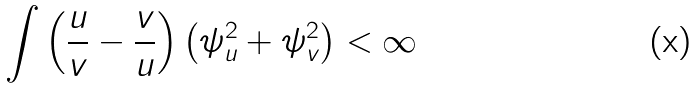<formula> <loc_0><loc_0><loc_500><loc_500>\int \left ( \frac { u } { v } - \frac { v } { u } \right ) \left ( \psi _ { u } ^ { 2 } + \psi _ { v } ^ { 2 } \right ) < \infty</formula> 